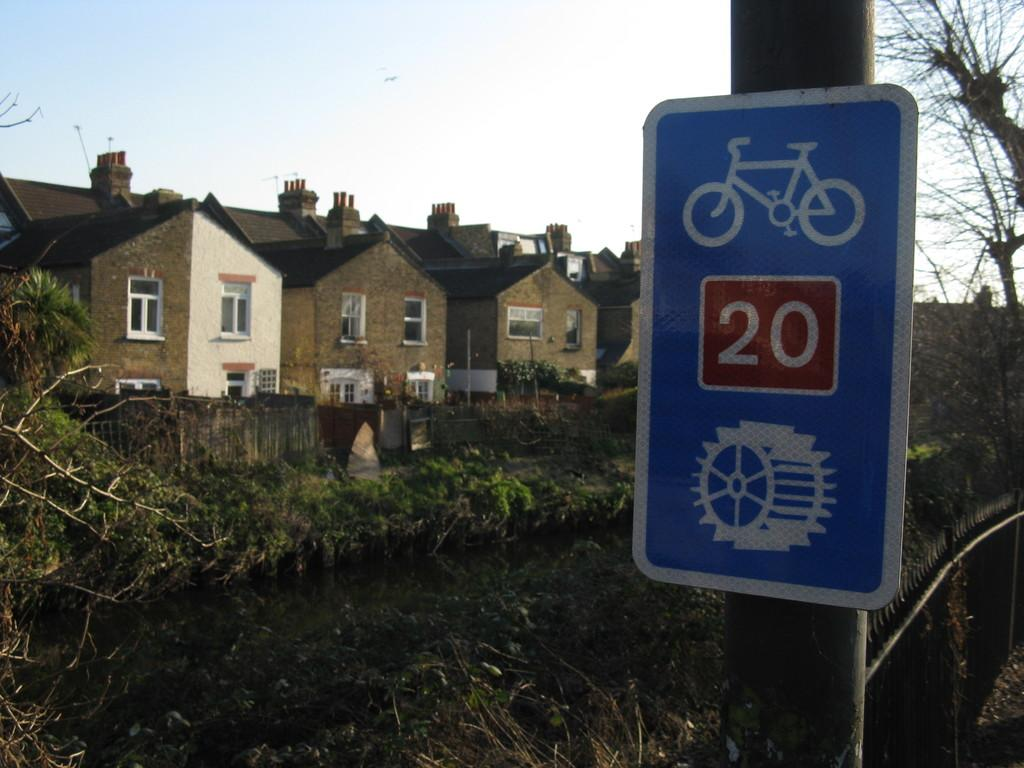<image>
Share a concise interpretation of the image provided. a sign with a bicycle on it is blue with a 20 and a sternwheel on it 